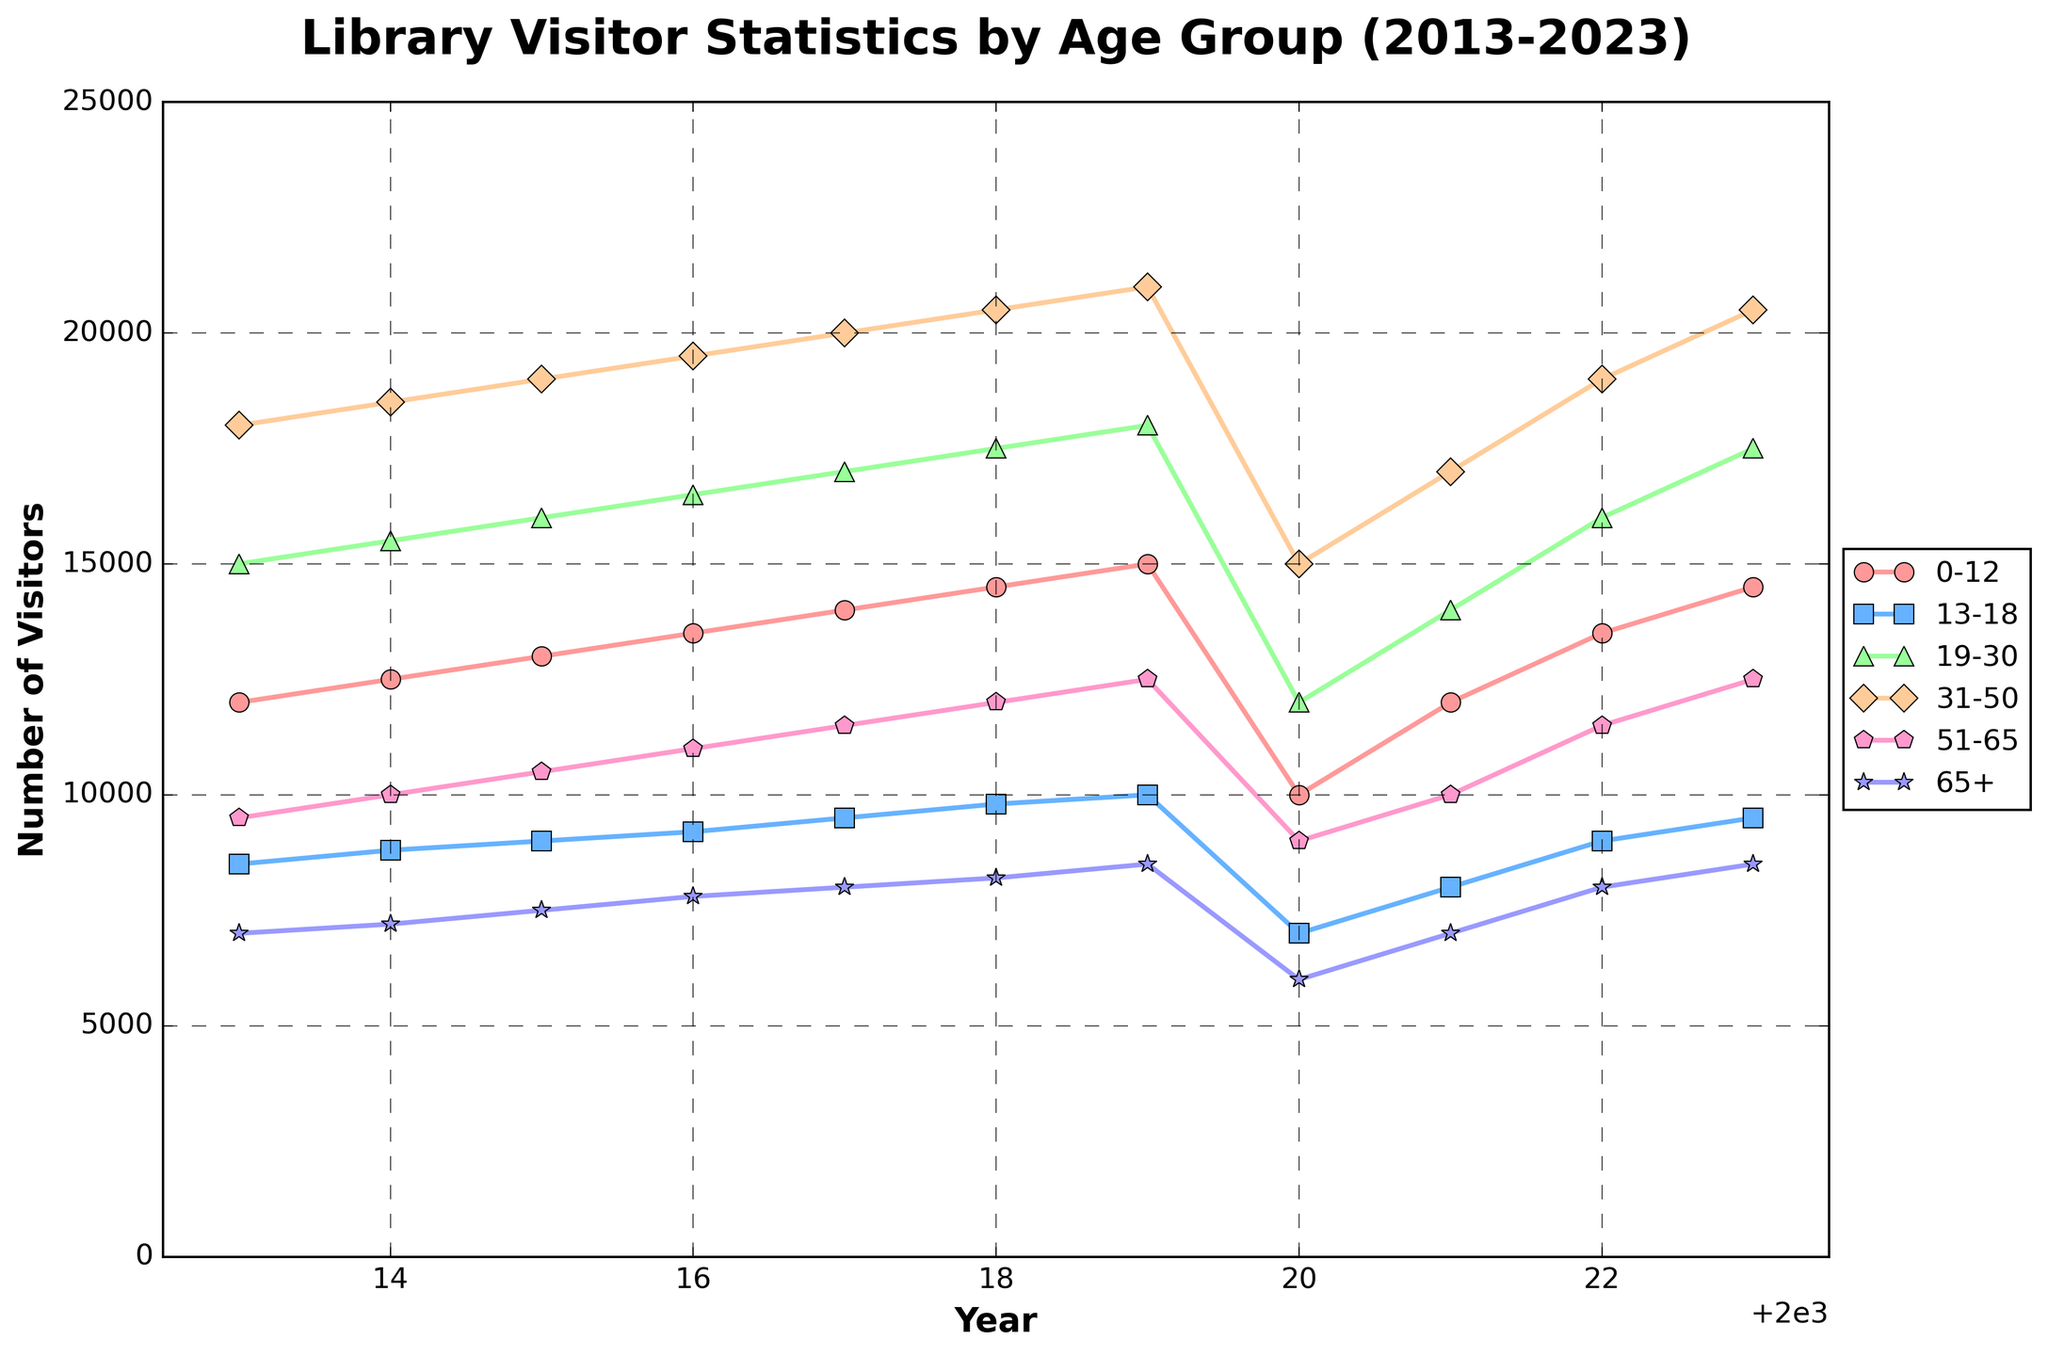What is the trend for visitors aged 0-12 over the years 2013-2023? The line representing the 0-12 age group shows a steady increase in the number of visitors from 2013 to 2019, a sharp drop in 2020, and then a rise again from 2021 to 2023.
Answer: Steady increase, drop in 2020, rise again In which year did visitors aged 19-30 reach their peak? By examining the highest point on the line for the 19-30 age group, we see the peak is in 2023.
Answer: 2023 Which age group had the most significant drop in visitors in 2020? Comparing the line segments for each age group, the 31-50 age group shows the steepest decline from 2019 to 2020.
Answer: 31-50 What is the total number of visitors for the 51-65 age group in 2015 and 2023? For 2015, it is 10500 and for 2023, it is 12500. Sum these values: 10500 + 12500 = 23000.
Answer: 23000 How did the number of visitors aged 65+ change from 2013 to 2023? The line for the 65+ age group shows a gradual increase from 2013 to 2019, a sharp drop in 2020, and a gradual rise and stabilization from 2021 to 2023.
Answer: Gradual increase, drop in 2020, gradual rise, stabilization Which age group has consistently had the lowest number of visitors throughout the decade? The line for the 65+ age group is consistently the lowest compared to the other groups throughout the years.
Answer: 65+ What was the impact of 2020 on all age groups' visitor numbers? All age groups experienced a significant drop in visitor numbers in 2020.
Answer: Significant drop for all groups Compare the number of visitors in the 0-12 and 31-50 age groups in 2021. The 0-12 age group had 12000 visitors, and the 31-50 age group had 17000 visitors in 2021.
Answer: 31-50 had more What is the average number of visitors for the 13-18 age group from 2013 to 2023? Sum of visitors from 2013 to 2023 is 8500 + 8800 + 9000 + 9200 + 9500 + 9800 + 10000 + 7000 + 8000 + 9000 + 9500 = 96400. The average is 96400 / 11 ≈ 8763.64.
Answer: 8763.64 From 2013 to 2023, which year had the lowest total number of visitors across all age groups? Sum visitors for each year and compare. The total for 2020 is 10000 + 7000 + 12000 + 15000 + 9000 + 6000 = 59000, which is the lowest among all years.
Answer: 2020 